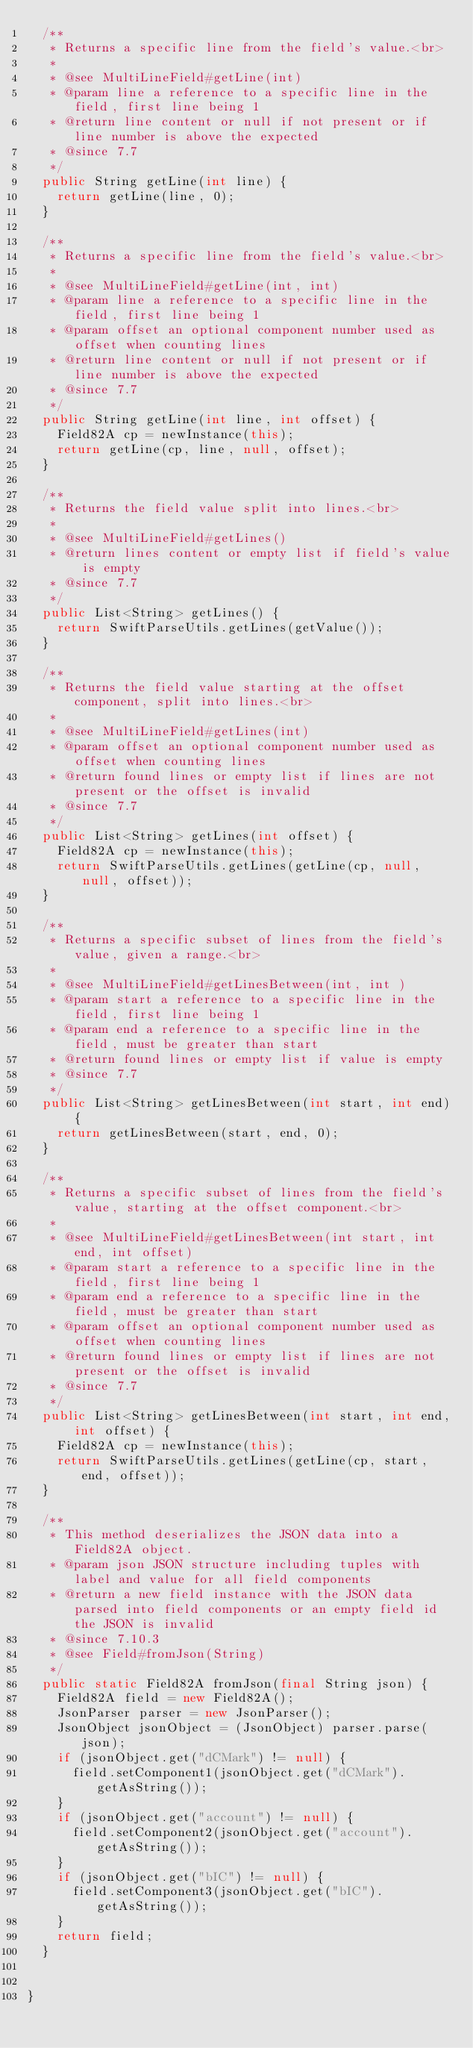<code> <loc_0><loc_0><loc_500><loc_500><_Java_>	/**
	 * Returns a specific line from the field's value.<br>
	 *
	 * @see MultiLineField#getLine(int)
	 * @param line a reference to a specific line in the field, first line being 1
	 * @return line content or null if not present or if line number is above the expected
	 * @since 7.7
	 */
	public String getLine(int line) {
		return getLine(line, 0);
	}
	
	/**
	 * Returns a specific line from the field's value.<br>
	 * 
	 * @see MultiLineField#getLine(int, int)
	 * @param line a reference to a specific line in the field, first line being 1
	 * @param offset an optional component number used as offset when counting lines
	 * @return line content or null if not present or if line number is above the expected
	 * @since 7.7
	 */
	public String getLine(int line, int offset) {
		Field82A cp = newInstance(this);
		return getLine(cp, line, null, offset);
	}
	
	/**
	 * Returns the field value split into lines.<br>
	 *
	 * @see MultiLineField#getLines()
	 * @return lines content or empty list if field's value is empty
	 * @since 7.7
	 */
	public List<String> getLines() {
		return SwiftParseUtils.getLines(getValue());
	}

	/**
	 * Returns the field value starting at the offset component, split into lines.<br>
	 *
	 * @see MultiLineField#getLines(int)
	 * @param offset an optional component number used as offset when counting lines
	 * @return found lines or empty list if lines are not present or the offset is invalid
	 * @since 7.7
	 */
	public List<String> getLines(int offset) {
		Field82A cp = newInstance(this);
		return SwiftParseUtils.getLines(getLine(cp, null, null, offset));
	}
	
	/**
	 * Returns a specific subset of lines from the field's value, given a range.<br>
	 *
	 * @see MultiLineField#getLinesBetween(int, int )
	 * @param start a reference to a specific line in the field, first line being 1
	 * @param end a reference to a specific line in the field, must be greater than start
	 * @return found lines or empty list if value is empty
	 * @since 7.7
	 */
	public List<String> getLinesBetween(int start, int end) {
		return getLinesBetween(start, end, 0);
	}

	/**
	 * Returns a specific subset of lines from the field's value, starting at the offset component.<br>
	 *
	 * @see MultiLineField#getLinesBetween(int start, int end, int offset)
	 * @param start a reference to a specific line in the field, first line being 1
	 * @param end a reference to a specific line in the field, must be greater than start
	 * @param offset an optional component number used as offset when counting lines
	 * @return found lines or empty list if lines are not present or the offset is invalid
	 * @since 7.7
	 */
	public List<String> getLinesBetween(int start, int end, int offset) {
		Field82A cp = newInstance(this);
		return SwiftParseUtils.getLines(getLine(cp, start, end, offset));
	}

	/**
	 * This method deserializes the JSON data into a Field82A object.
	 * @param json JSON structure including tuples with label and value for all field components
	 * @return a new field instance with the JSON data parsed into field components or an empty field id the JSON is invalid
	 * @since 7.10.3
	 * @see Field#fromJson(String)
	 */
	public static Field82A fromJson(final String json) {
		Field82A field = new Field82A();
		JsonParser parser = new JsonParser();
		JsonObject jsonObject = (JsonObject) parser.parse(json);
		if (jsonObject.get("dCMark") != null) {
			field.setComponent1(jsonObject.get("dCMark").getAsString());
		}
		if (jsonObject.get("account") != null) {
			field.setComponent2(jsonObject.get("account").getAsString());
		}
		if (jsonObject.get("bIC") != null) {
			field.setComponent3(jsonObject.get("bIC").getAsString());
		}
		return field;
	}
	

}
</code> 